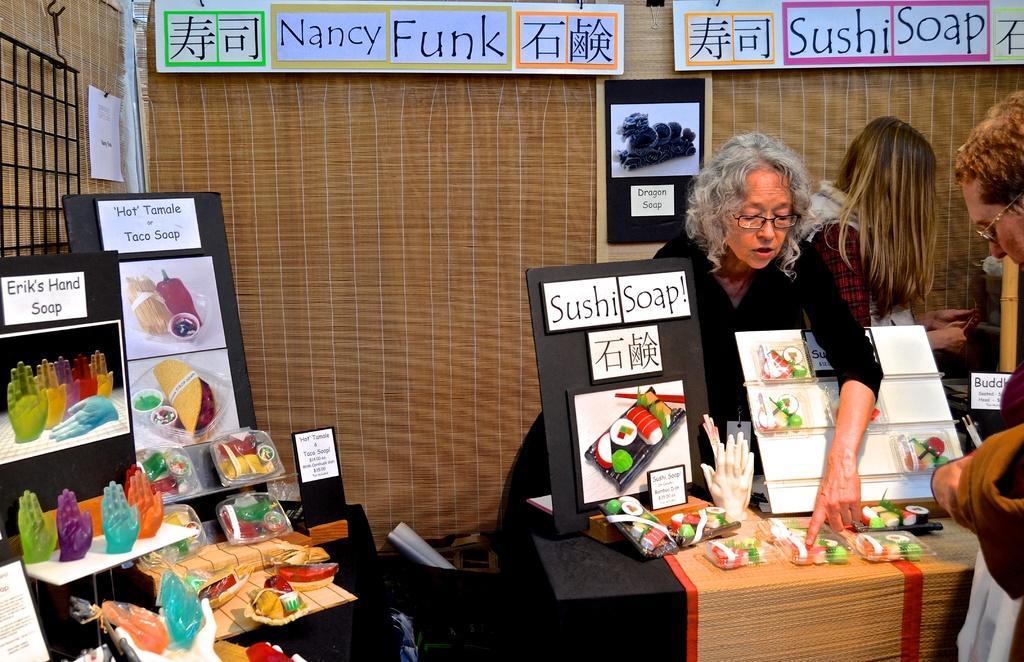Who is the main subject in the image? There is a woman in the image. What is the woman doing in the image? The woman is explaining something. What is the setting of the image? There is a table and a board in the image, suggesting a classroom or presentation setting. What can be seen on the table in the image? There are objects on the table in the image. Can you describe the person standing at the back of the image? There is a person standing at the back of the image, but their role or activity is not clear from the provided facts. What is the background of the image? There is a wall in the image, which could be part of a room or building. What type of hole can be seen in the image? There is no hole present in the image. 